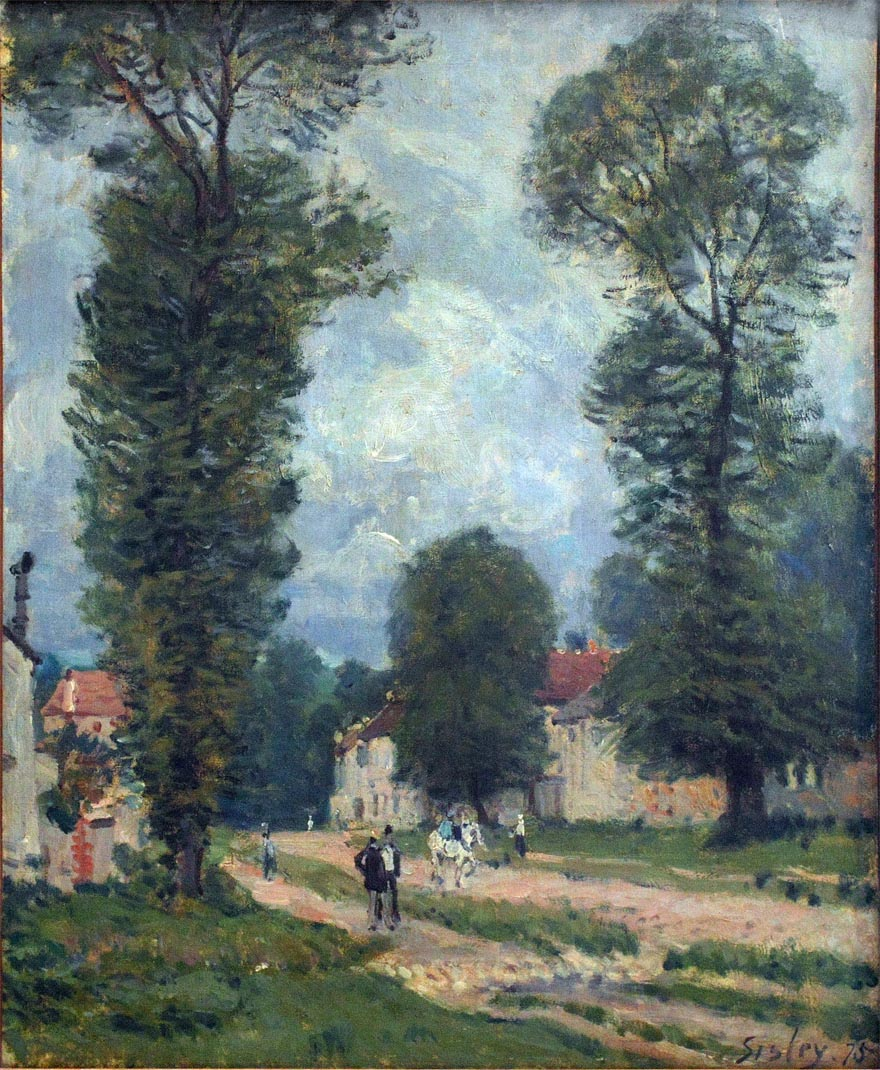Can you create a short story inspired by this painting? In a quiet village nestled within the lush countryside, there lived a young girl named Anna. Every afternoon, she would wander down the dirt road that meandered through the village, her heart brimming with curiosity and wonder. Her favorite spot was beneath the tall twin trees on the edge of the road, where the leaves whispered secrets in the gentle breeze. One day, as she sat there reading her favorite book, a stranger on horseback passed by and greeted her. Little did she know, this chance encounter would lead to adventures beyond her wildest dreams. For the stranger was a lost prince, seeking his way back to his kingdom under the guidance of a magical map. Together, they embarked on a journey that would take them through enchanted forests, ancient ruins, and far beyond the horizon, where Anna's destiny awaited. Wow, that's a great story! Does the man on horseback in the painting have a similar adventurous spirit? Indeed, the man on horseback in the painting could very well possess an adventurous spirit. The way he travels, seemingly in no rush, hints at a person who enjoys the journey as much as the destination. He might be a traveler exploring new lands, a merchant bringing goods to distant places, or even a local hero returning from his latest adventure. His presence adds a sense of unfolding stories and untold adventures to this peaceful rural setting. 